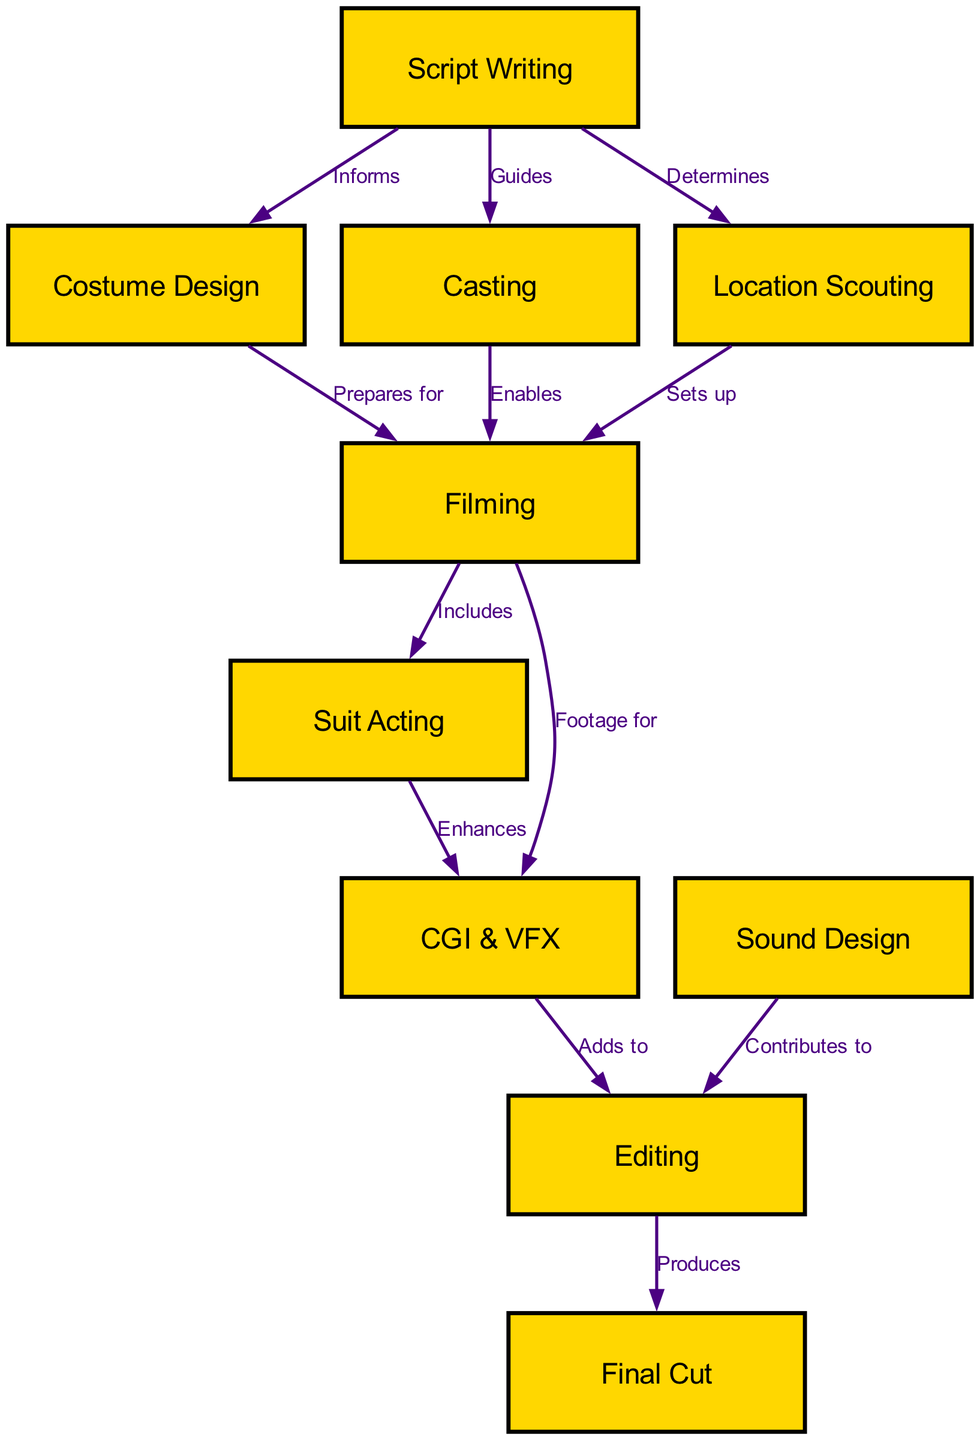What is the first step in the Kamen Rider episode production process? According to the diagram, the first step is "Script Writing," as it is the initial node listed and shows the starting point of the production process.
Answer: Script Writing How many nodes are in the diagram? The diagram includes 10 distinct nodes as listed in the data provided. Each node represents a specific step or component in the production process.
Answer: 10 What step prepares for filming? "Costume Design" is indicated as a step that prepares for filming, evidenced by the edge from "Costume Design" to "Filming" labeled as "Prepares for."
Answer: Costume Design Which node determines location scouting? "Script Writing" is the node that determines "Location Scouting," as evidenced by the directed edge labeled "Determines" from "Script Writing" to "Location Scouting."
Answer: Script Writing What involves the use of CGI & VFX? "Filming" involves the use of "CGI & VFX," as shown by the edge from "Filming" to "CGI & VFX," indicating that footage produced during filming is used for this purpose.
Answer: Filming What contributes to the editing process in Kamen Rider production? "Sound Design" contributes to the editing process, as indicated by the edge from "Sound Design" to "Editing" labeled as "Contributes to."
Answer: Sound Design How does suit acting influence CGI & VFX? "Suit Acting" enhances "CGI & VFX," as shown by the directed edge from "Suit Acting" to "CGI & VFX," indicating that the performances in the suits improve the quality of CGI and VFX in the episode.
Answer: Enhances What produces the final output of the episode? "Editing" is responsible for producing the "Final Cut," as shown by the directed edge from "Editing" to "Final Cut," indicating that the editing process culminates in the final version of the episode.
Answer: Editing How many distinct types of design are indicated before filming? The diagram shows two distinct types of design before filming: "Costume Design" and "Sound Design" as the steps represented prior to the main filming stage.
Answer: 2 What guides the casting process in episode production? "Script Writing" guides the casting process, which is indicated by the edge labeled "Guides" from "Script Writing" to "Casting," establishing that the script helps in deciding the cast.
Answer: Script Writing 